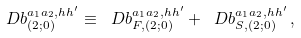<formula> <loc_0><loc_0><loc_500><loc_500>\ D b ^ { a _ { 1 } a _ { 2 } , h h ^ { \prime } } _ { ( 2 ; 0 ) } \equiv \ D b ^ { a _ { 1 } a _ { 2 } , h h ^ { \prime } } _ { F , ( 2 ; 0 ) } + \ D b ^ { a _ { 1 } a _ { 2 } , h h ^ { \prime } } _ { S , ( 2 ; 0 ) } \, ,</formula> 